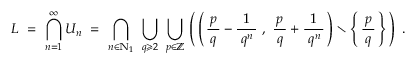Convert formula to latex. <formula><loc_0><loc_0><loc_500><loc_500>L = \bigcap _ { n = 1 } ^ { \infty } U _ { n } = \bigcap _ { n \in \mathbb { N } _ { 1 } } \bigcup _ { q \geqslant 2 } \bigcup _ { p \in \mathbb { Z } } \, \left ( \, \left ( \, { \frac { \, p \, } { q } } - { \frac { 1 } { \, q ^ { n } \, } } , { \frac { \, p \, } { q } } + { \frac { 1 } { \, q ^ { n } \, } } \, \right ) \ \left \{ \, { \frac { \, p \, } { q } } \, \right \} \, \right ) .</formula> 